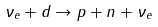<formula> <loc_0><loc_0><loc_500><loc_500>\nu _ { e } + d \rightarrow p + n + \nu _ { e }</formula> 